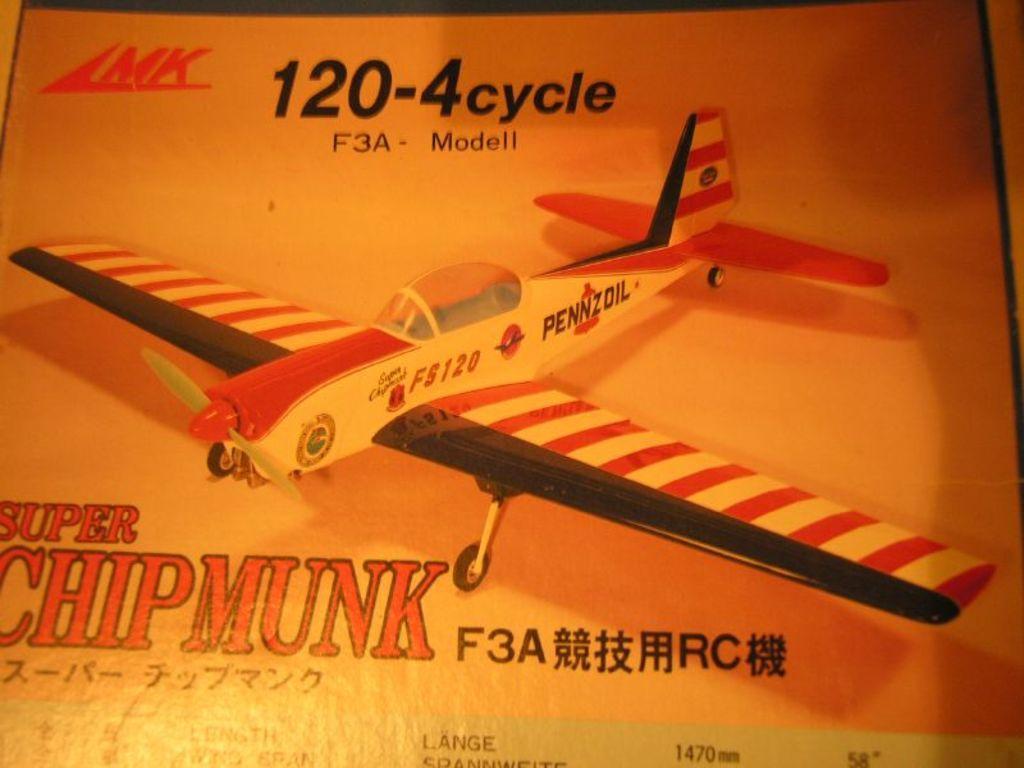How would you summarize this image in a sentence or two? Here we can see poster,in this poster we can see an airplane. 